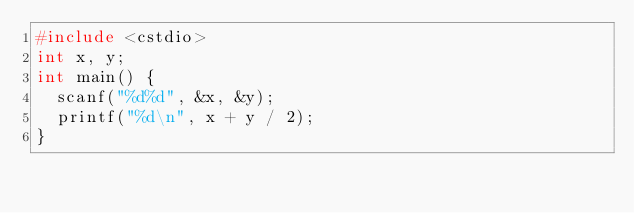Convert code to text. <code><loc_0><loc_0><loc_500><loc_500><_C++_>#include <cstdio>
int x, y;
int main() {
  scanf("%d%d", &x, &y);
  printf("%d\n", x + y / 2);
}</code> 